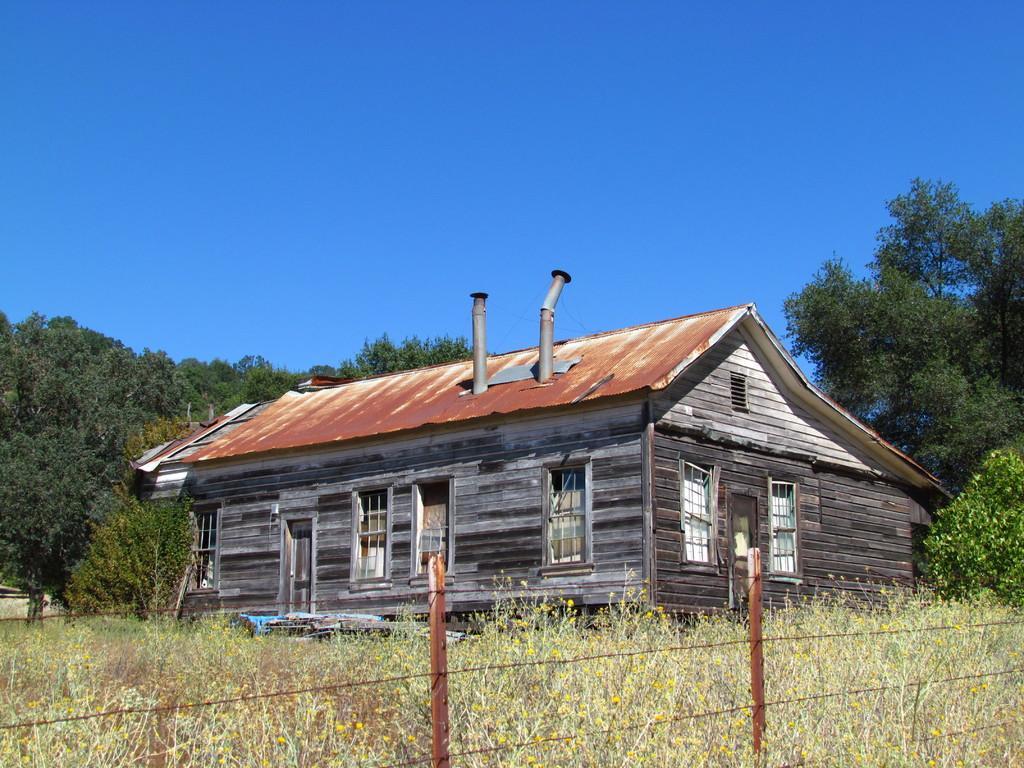Could you give a brief overview of what you see in this image? This picture shows a wooden house and we see trees and grass on the ground and we see fence and a blue sky. 